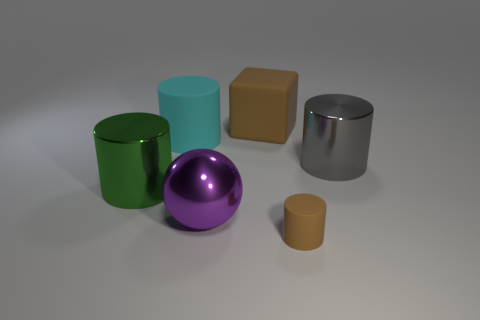Is there anything else that has the same size as the brown cylinder?
Offer a terse response. No. There is a cylinder that is the same color as the big matte block; what size is it?
Ensure brevity in your answer.  Small. What number of things are cyan things or brown matte things that are to the right of the brown matte block?
Your answer should be very brief. 2. Are there any brown cylinders made of the same material as the big sphere?
Your answer should be very brief. No. How many brown rubber things are both behind the large purple metallic ball and in front of the rubber cube?
Ensure brevity in your answer.  0. What is the big cylinder that is to the right of the brown cube made of?
Ensure brevity in your answer.  Metal. There is another cylinder that is made of the same material as the big cyan cylinder; what is its size?
Give a very brief answer. Small. Are there any matte cylinders on the right side of the cyan rubber object?
Provide a succinct answer. Yes. There is a brown object that is the same shape as the big green object; what size is it?
Your answer should be compact. Small. Do the small thing and the large matte thing right of the large ball have the same color?
Provide a short and direct response. Yes. 